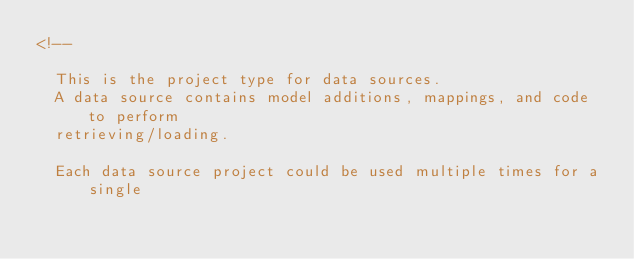<code> <loc_0><loc_0><loc_500><loc_500><_XML_><!--

  This is the project type for data sources.
  A data source contains model additions, mappings, and code to perform
  retrieving/loading.

  Each data source project could be used multiple times for a single</code> 